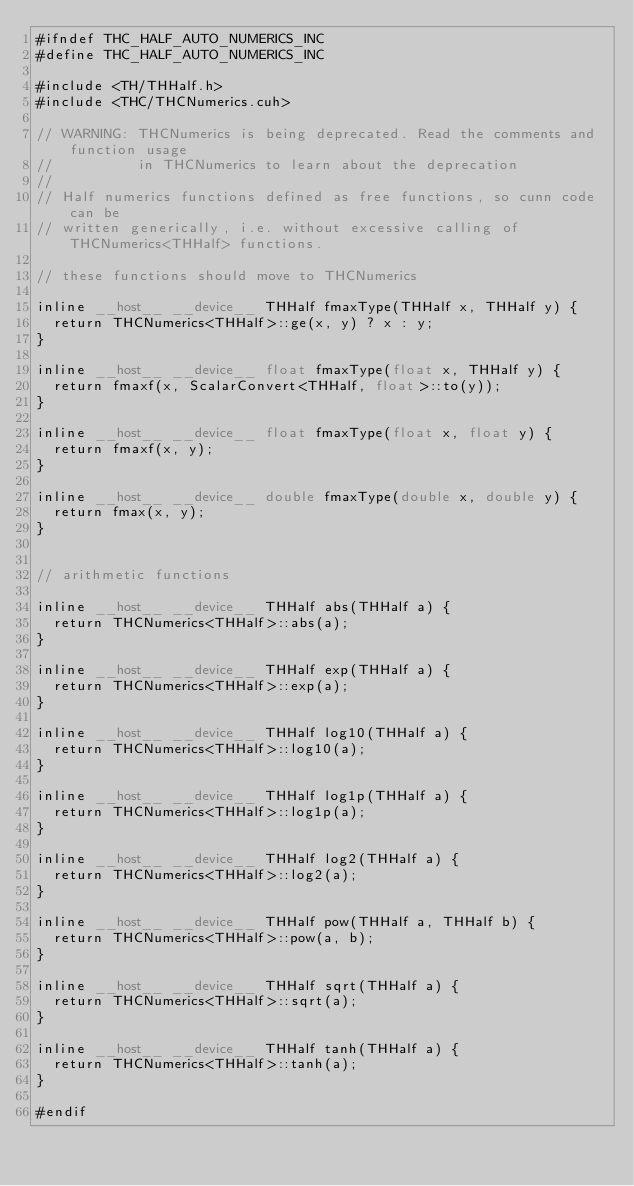<code> <loc_0><loc_0><loc_500><loc_500><_Cuda_>#ifndef THC_HALF_AUTO_NUMERICS_INC
#define THC_HALF_AUTO_NUMERICS_INC

#include <TH/THHalf.h>
#include <THC/THCNumerics.cuh>

// WARNING: THCNumerics is being deprecated. Read the comments and function usage
//          in THCNumerics to learn about the deprecation
//
// Half numerics functions defined as free functions, so cunn code can be
// written generically, i.e. without excessive calling of THCNumerics<THHalf> functions.

// these functions should move to THCNumerics

inline __host__ __device__ THHalf fmaxType(THHalf x, THHalf y) {
  return THCNumerics<THHalf>::ge(x, y) ? x : y;
}

inline __host__ __device__ float fmaxType(float x, THHalf y) {
  return fmaxf(x, ScalarConvert<THHalf, float>::to(y));
}

inline __host__ __device__ float fmaxType(float x, float y) {
  return fmaxf(x, y);
}

inline __host__ __device__ double fmaxType(double x, double y) {
  return fmax(x, y);
}


// arithmetic functions

inline __host__ __device__ THHalf abs(THHalf a) {
  return THCNumerics<THHalf>::abs(a);
}

inline __host__ __device__ THHalf exp(THHalf a) {
  return THCNumerics<THHalf>::exp(a);
}

inline __host__ __device__ THHalf log10(THHalf a) {
  return THCNumerics<THHalf>::log10(a);
}

inline __host__ __device__ THHalf log1p(THHalf a) {
  return THCNumerics<THHalf>::log1p(a);
}

inline __host__ __device__ THHalf log2(THHalf a) {
  return THCNumerics<THHalf>::log2(a);
}

inline __host__ __device__ THHalf pow(THHalf a, THHalf b) {
  return THCNumerics<THHalf>::pow(a, b);
}

inline __host__ __device__ THHalf sqrt(THHalf a) {
  return THCNumerics<THHalf>::sqrt(a);
}

inline __host__ __device__ THHalf tanh(THHalf a) {
  return THCNumerics<THHalf>::tanh(a);
}

#endif
</code> 